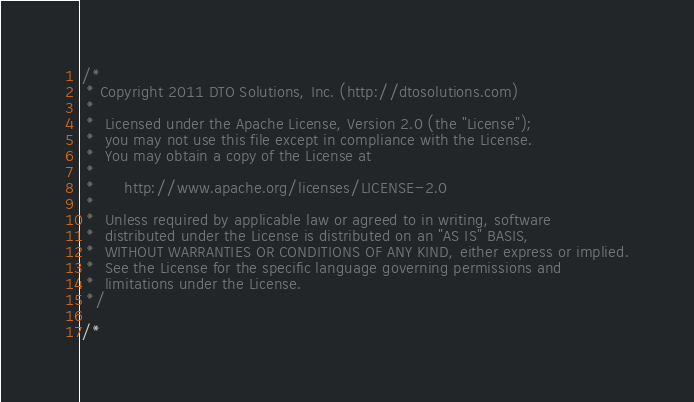Convert code to text. <code><loc_0><loc_0><loc_500><loc_500><_Java_>/*
 * Copyright 2011 DTO Solutions, Inc. (http://dtosolutions.com)
 *
 *  Licensed under the Apache License, Version 2.0 (the "License");
 *  you may not use this file except in compliance with the License.
 *  You may obtain a copy of the License at
 *
 *      http://www.apache.org/licenses/LICENSE-2.0
 *
 *  Unless required by applicable law or agreed to in writing, software
 *  distributed under the License is distributed on an "AS IS" BASIS,
 *  WITHOUT WARRANTIES OR CONDITIONS OF ANY KIND, either express or implied.
 *  See the License for the specific language governing permissions and
 *  limitations under the License.
 */

/*</code> 